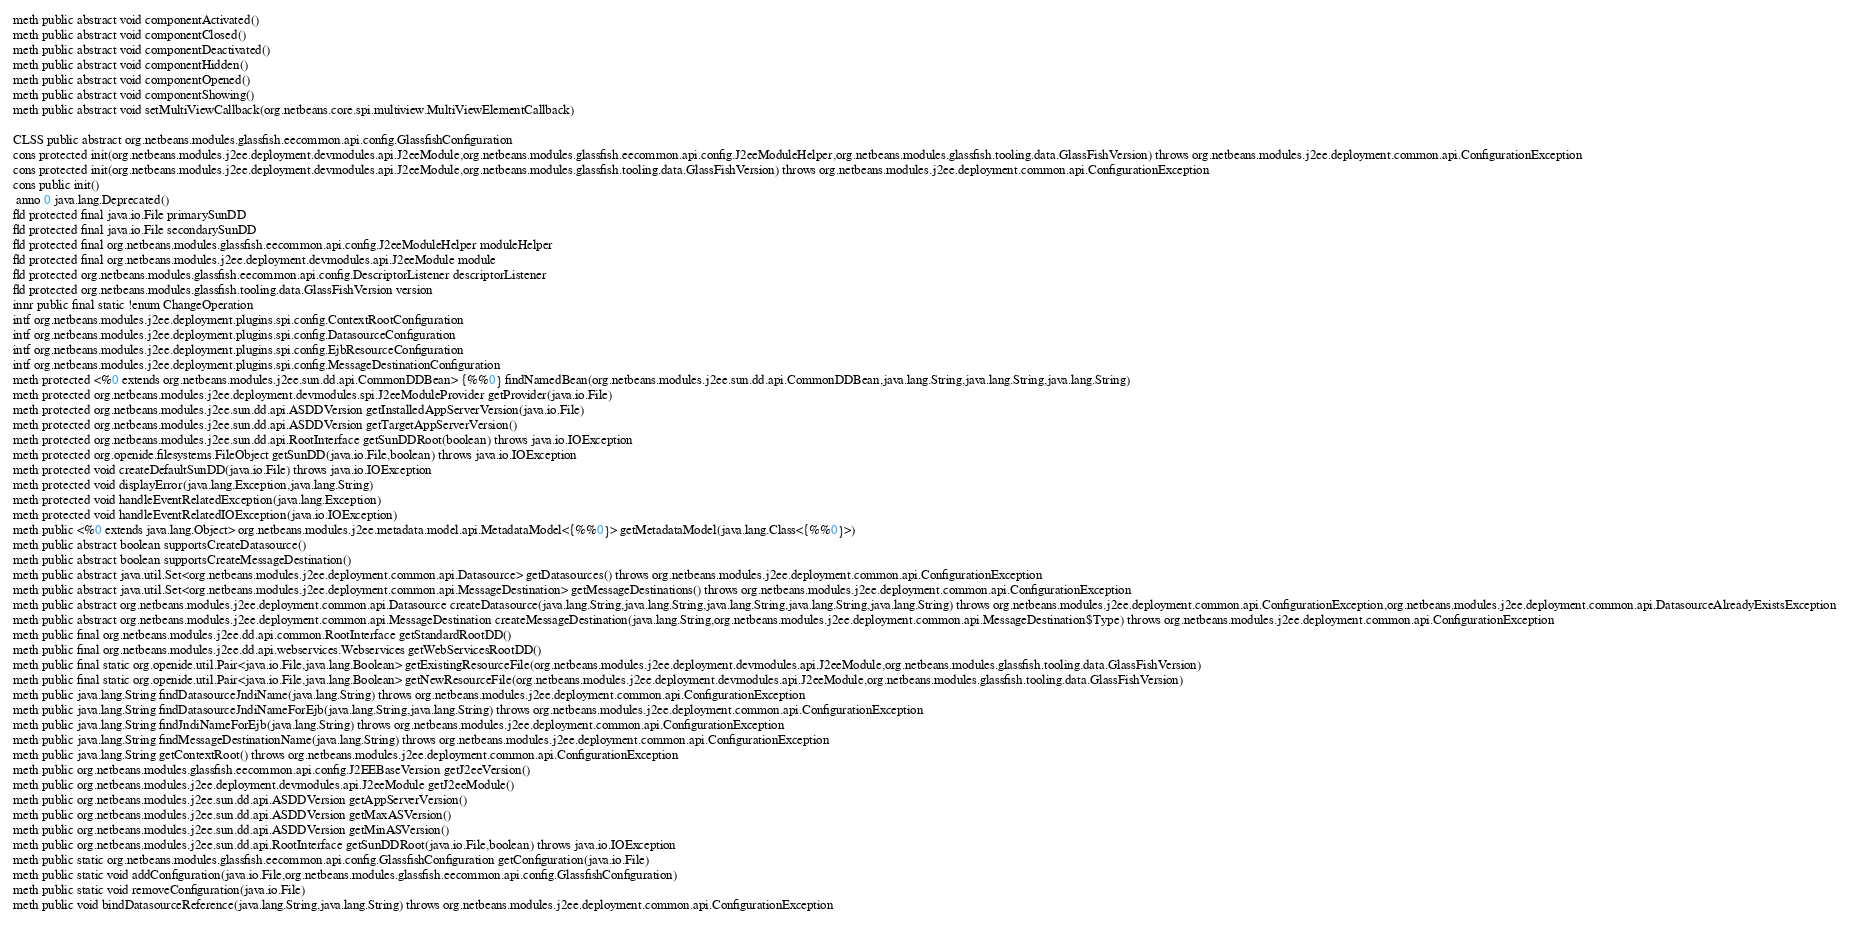<code> <loc_0><loc_0><loc_500><loc_500><_SML_>meth public abstract void componentActivated()
meth public abstract void componentClosed()
meth public abstract void componentDeactivated()
meth public abstract void componentHidden()
meth public abstract void componentOpened()
meth public abstract void componentShowing()
meth public abstract void setMultiViewCallback(org.netbeans.core.spi.multiview.MultiViewElementCallback)

CLSS public abstract org.netbeans.modules.glassfish.eecommon.api.config.GlassfishConfiguration
cons protected init(org.netbeans.modules.j2ee.deployment.devmodules.api.J2eeModule,org.netbeans.modules.glassfish.eecommon.api.config.J2eeModuleHelper,org.netbeans.modules.glassfish.tooling.data.GlassFishVersion) throws org.netbeans.modules.j2ee.deployment.common.api.ConfigurationException
cons protected init(org.netbeans.modules.j2ee.deployment.devmodules.api.J2eeModule,org.netbeans.modules.glassfish.tooling.data.GlassFishVersion) throws org.netbeans.modules.j2ee.deployment.common.api.ConfigurationException
cons public init()
 anno 0 java.lang.Deprecated()
fld protected final java.io.File primarySunDD
fld protected final java.io.File secondarySunDD
fld protected final org.netbeans.modules.glassfish.eecommon.api.config.J2eeModuleHelper moduleHelper
fld protected final org.netbeans.modules.j2ee.deployment.devmodules.api.J2eeModule module
fld protected org.netbeans.modules.glassfish.eecommon.api.config.DescriptorListener descriptorListener
fld protected org.netbeans.modules.glassfish.tooling.data.GlassFishVersion version
innr public final static !enum ChangeOperation
intf org.netbeans.modules.j2ee.deployment.plugins.spi.config.ContextRootConfiguration
intf org.netbeans.modules.j2ee.deployment.plugins.spi.config.DatasourceConfiguration
intf org.netbeans.modules.j2ee.deployment.plugins.spi.config.EjbResourceConfiguration
intf org.netbeans.modules.j2ee.deployment.plugins.spi.config.MessageDestinationConfiguration
meth protected <%0 extends org.netbeans.modules.j2ee.sun.dd.api.CommonDDBean> {%%0} findNamedBean(org.netbeans.modules.j2ee.sun.dd.api.CommonDDBean,java.lang.String,java.lang.String,java.lang.String)
meth protected org.netbeans.modules.j2ee.deployment.devmodules.spi.J2eeModuleProvider getProvider(java.io.File)
meth protected org.netbeans.modules.j2ee.sun.dd.api.ASDDVersion getInstalledAppServerVersion(java.io.File)
meth protected org.netbeans.modules.j2ee.sun.dd.api.ASDDVersion getTargetAppServerVersion()
meth protected org.netbeans.modules.j2ee.sun.dd.api.RootInterface getSunDDRoot(boolean) throws java.io.IOException
meth protected org.openide.filesystems.FileObject getSunDD(java.io.File,boolean) throws java.io.IOException
meth protected void createDefaultSunDD(java.io.File) throws java.io.IOException
meth protected void displayError(java.lang.Exception,java.lang.String)
meth protected void handleEventRelatedException(java.lang.Exception)
meth protected void handleEventRelatedIOException(java.io.IOException)
meth public <%0 extends java.lang.Object> org.netbeans.modules.j2ee.metadata.model.api.MetadataModel<{%%0}> getMetadataModel(java.lang.Class<{%%0}>)
meth public abstract boolean supportsCreateDatasource()
meth public abstract boolean supportsCreateMessageDestination()
meth public abstract java.util.Set<org.netbeans.modules.j2ee.deployment.common.api.Datasource> getDatasources() throws org.netbeans.modules.j2ee.deployment.common.api.ConfigurationException
meth public abstract java.util.Set<org.netbeans.modules.j2ee.deployment.common.api.MessageDestination> getMessageDestinations() throws org.netbeans.modules.j2ee.deployment.common.api.ConfigurationException
meth public abstract org.netbeans.modules.j2ee.deployment.common.api.Datasource createDatasource(java.lang.String,java.lang.String,java.lang.String,java.lang.String,java.lang.String) throws org.netbeans.modules.j2ee.deployment.common.api.ConfigurationException,org.netbeans.modules.j2ee.deployment.common.api.DatasourceAlreadyExistsException
meth public abstract org.netbeans.modules.j2ee.deployment.common.api.MessageDestination createMessageDestination(java.lang.String,org.netbeans.modules.j2ee.deployment.common.api.MessageDestination$Type) throws org.netbeans.modules.j2ee.deployment.common.api.ConfigurationException
meth public final org.netbeans.modules.j2ee.dd.api.common.RootInterface getStandardRootDD()
meth public final org.netbeans.modules.j2ee.dd.api.webservices.Webservices getWebServicesRootDD()
meth public final static org.openide.util.Pair<java.io.File,java.lang.Boolean> getExistingResourceFile(org.netbeans.modules.j2ee.deployment.devmodules.api.J2eeModule,org.netbeans.modules.glassfish.tooling.data.GlassFishVersion)
meth public final static org.openide.util.Pair<java.io.File,java.lang.Boolean> getNewResourceFile(org.netbeans.modules.j2ee.deployment.devmodules.api.J2eeModule,org.netbeans.modules.glassfish.tooling.data.GlassFishVersion)
meth public java.lang.String findDatasourceJndiName(java.lang.String) throws org.netbeans.modules.j2ee.deployment.common.api.ConfigurationException
meth public java.lang.String findDatasourceJndiNameForEjb(java.lang.String,java.lang.String) throws org.netbeans.modules.j2ee.deployment.common.api.ConfigurationException
meth public java.lang.String findJndiNameForEjb(java.lang.String) throws org.netbeans.modules.j2ee.deployment.common.api.ConfigurationException
meth public java.lang.String findMessageDestinationName(java.lang.String) throws org.netbeans.modules.j2ee.deployment.common.api.ConfigurationException
meth public java.lang.String getContextRoot() throws org.netbeans.modules.j2ee.deployment.common.api.ConfigurationException
meth public org.netbeans.modules.glassfish.eecommon.api.config.J2EEBaseVersion getJ2eeVersion()
meth public org.netbeans.modules.j2ee.deployment.devmodules.api.J2eeModule getJ2eeModule()
meth public org.netbeans.modules.j2ee.sun.dd.api.ASDDVersion getAppServerVersion()
meth public org.netbeans.modules.j2ee.sun.dd.api.ASDDVersion getMaxASVersion()
meth public org.netbeans.modules.j2ee.sun.dd.api.ASDDVersion getMinASVersion()
meth public org.netbeans.modules.j2ee.sun.dd.api.RootInterface getSunDDRoot(java.io.File,boolean) throws java.io.IOException
meth public static org.netbeans.modules.glassfish.eecommon.api.config.GlassfishConfiguration getConfiguration(java.io.File)
meth public static void addConfiguration(java.io.File,org.netbeans.modules.glassfish.eecommon.api.config.GlassfishConfiguration)
meth public static void removeConfiguration(java.io.File)
meth public void bindDatasourceReference(java.lang.String,java.lang.String) throws org.netbeans.modules.j2ee.deployment.common.api.ConfigurationException</code> 